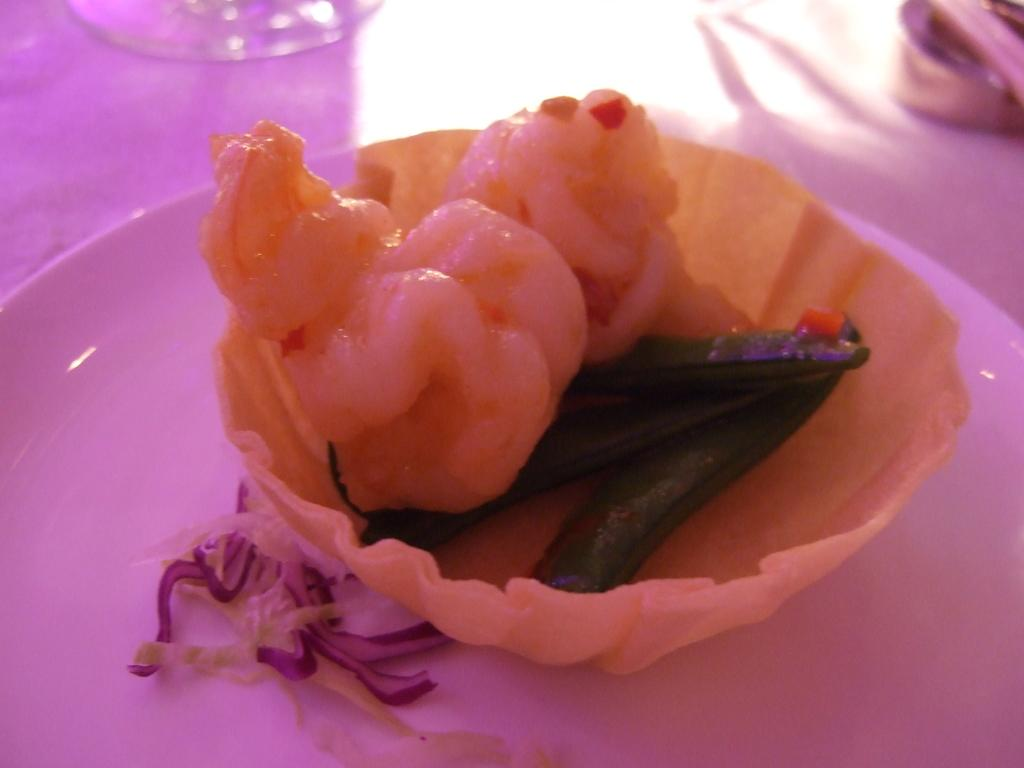What is located in the center of the image? There is a platform in the center of the image. What is placed on the platform? There is a plate on the platform. What can be found on the plate? There are food items on the plate. Are there any other objects on the platform besides the plate? Yes, there are objects on the platform. Where is the office located in the image? There is no office present in the image. What time is it according to the clock in the image? There is no clock present in the image. 